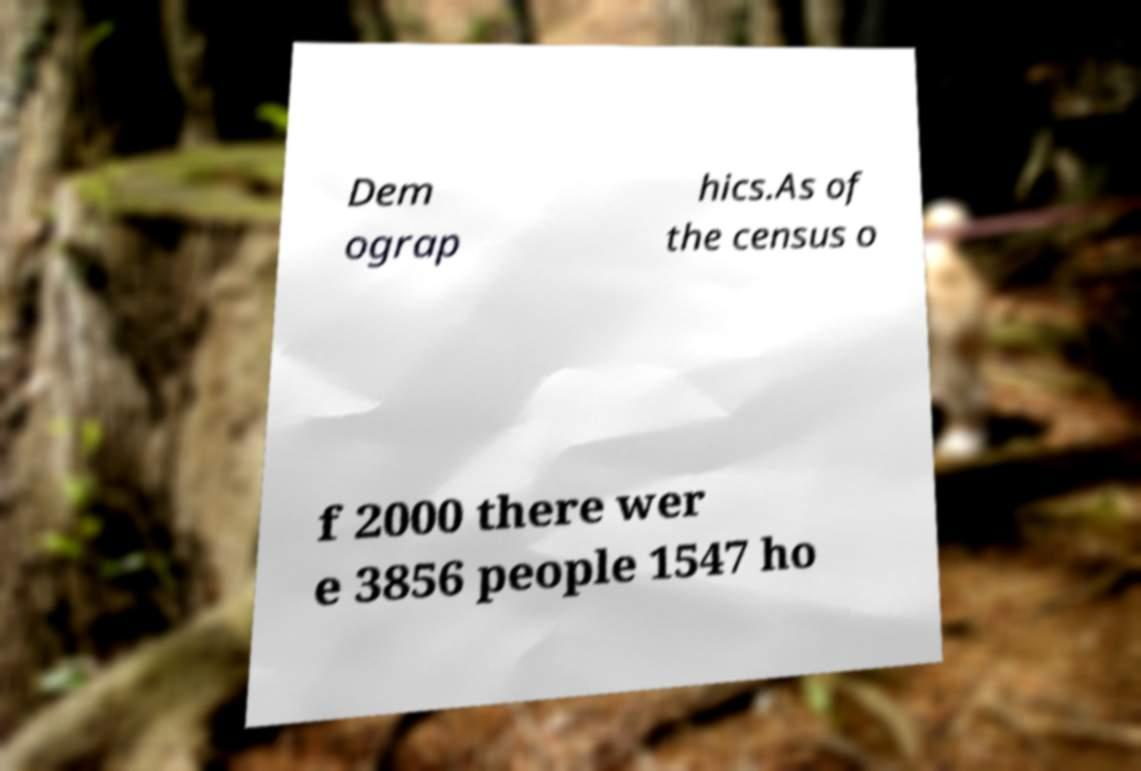Can you accurately transcribe the text from the provided image for me? Dem ograp hics.As of the census o f 2000 there wer e 3856 people 1547 ho 